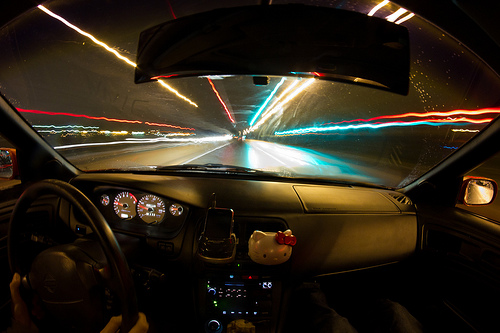<image>
Can you confirm if the road is above the dashboard? No. The road is not positioned above the dashboard. The vertical arrangement shows a different relationship. 